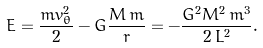Convert formula to latex. <formula><loc_0><loc_0><loc_500><loc_500>E = \frac { m v _ { \theta } ^ { 2 } } { 2 } - G \frac { M \, m } { r } = - \frac { G ^ { 2 } M ^ { 2 } \, m ^ { 3 } } { 2 \, L ^ { 2 } } .</formula> 